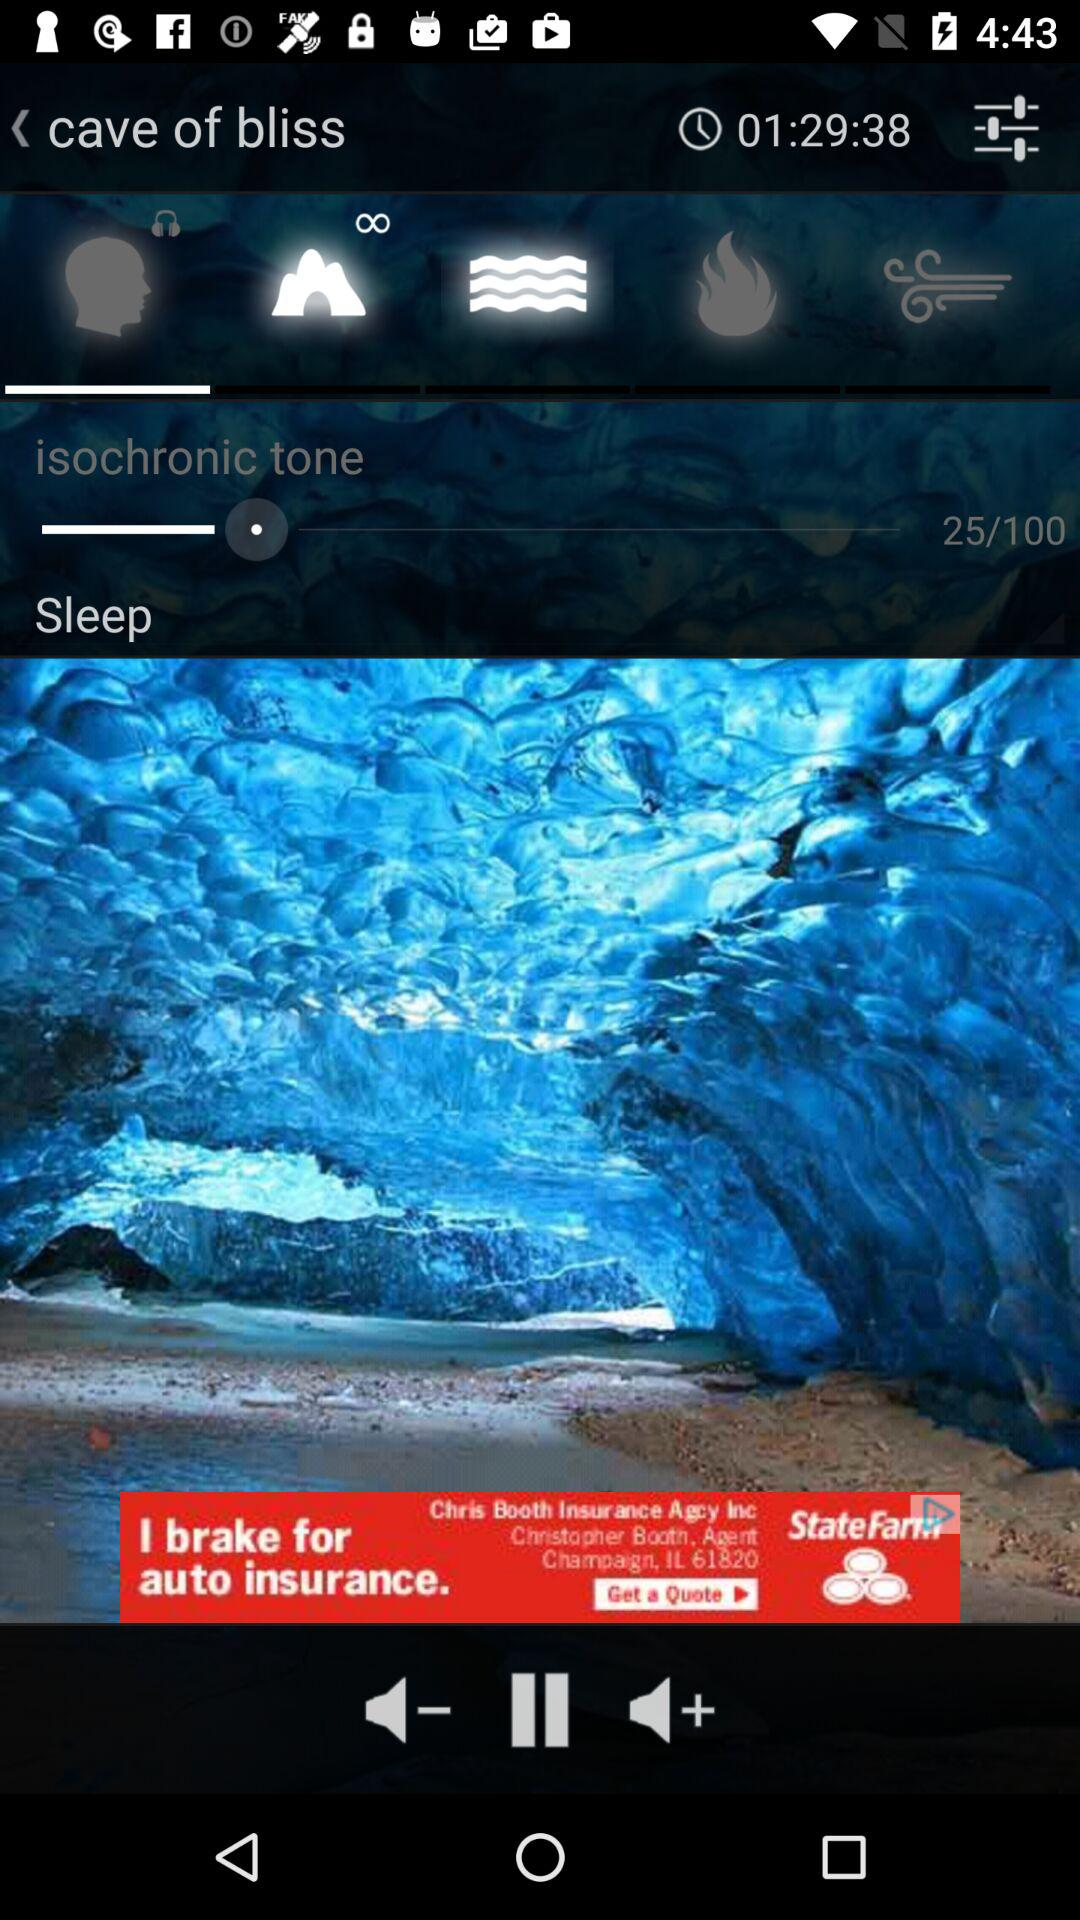What is the total number of isochronic tone? The total number is 100. 